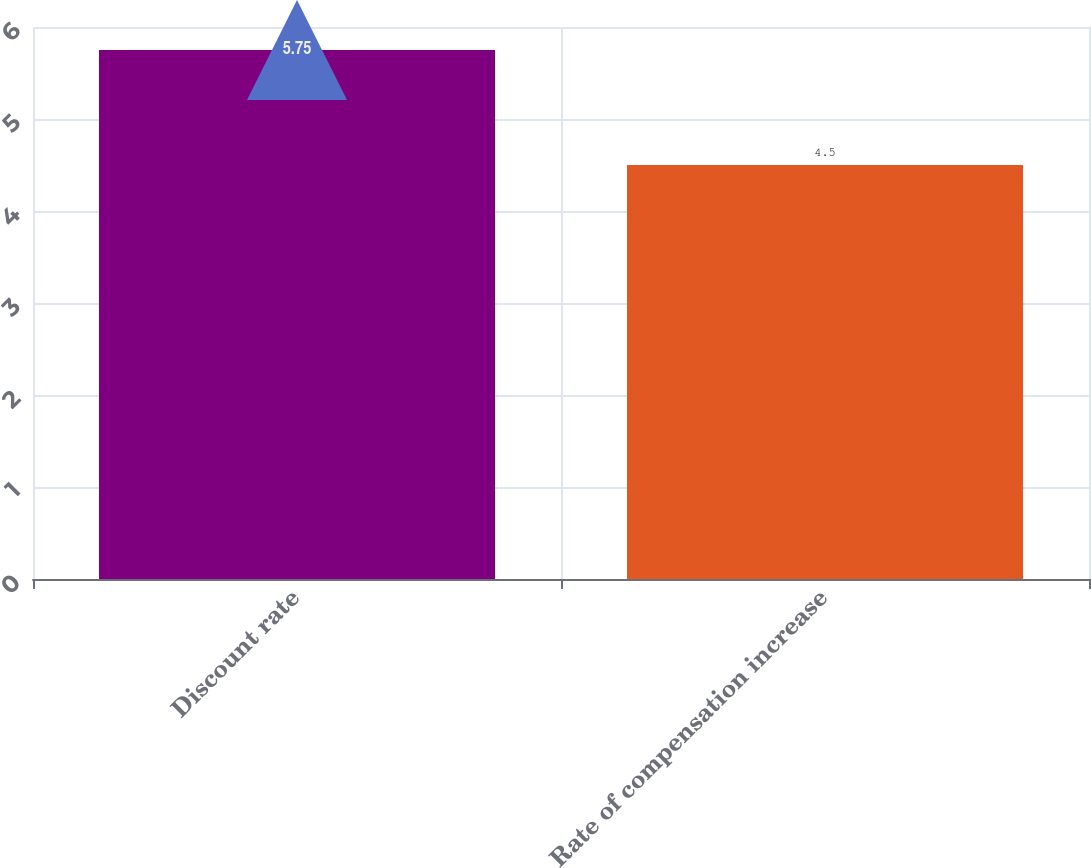<chart> <loc_0><loc_0><loc_500><loc_500><bar_chart><fcel>Discount rate<fcel>Rate of compensation increase<nl><fcel>5.75<fcel>4.5<nl></chart> 